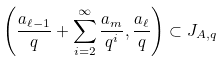Convert formula to latex. <formula><loc_0><loc_0><loc_500><loc_500>\left ( \frac { a _ { \ell - 1 } } { q } + \sum _ { i = 2 } ^ { \infty } \frac { a _ { m } } { q ^ { i } } , \frac { a _ { \ell } } { q } \right ) \subset J _ { A , q }</formula> 